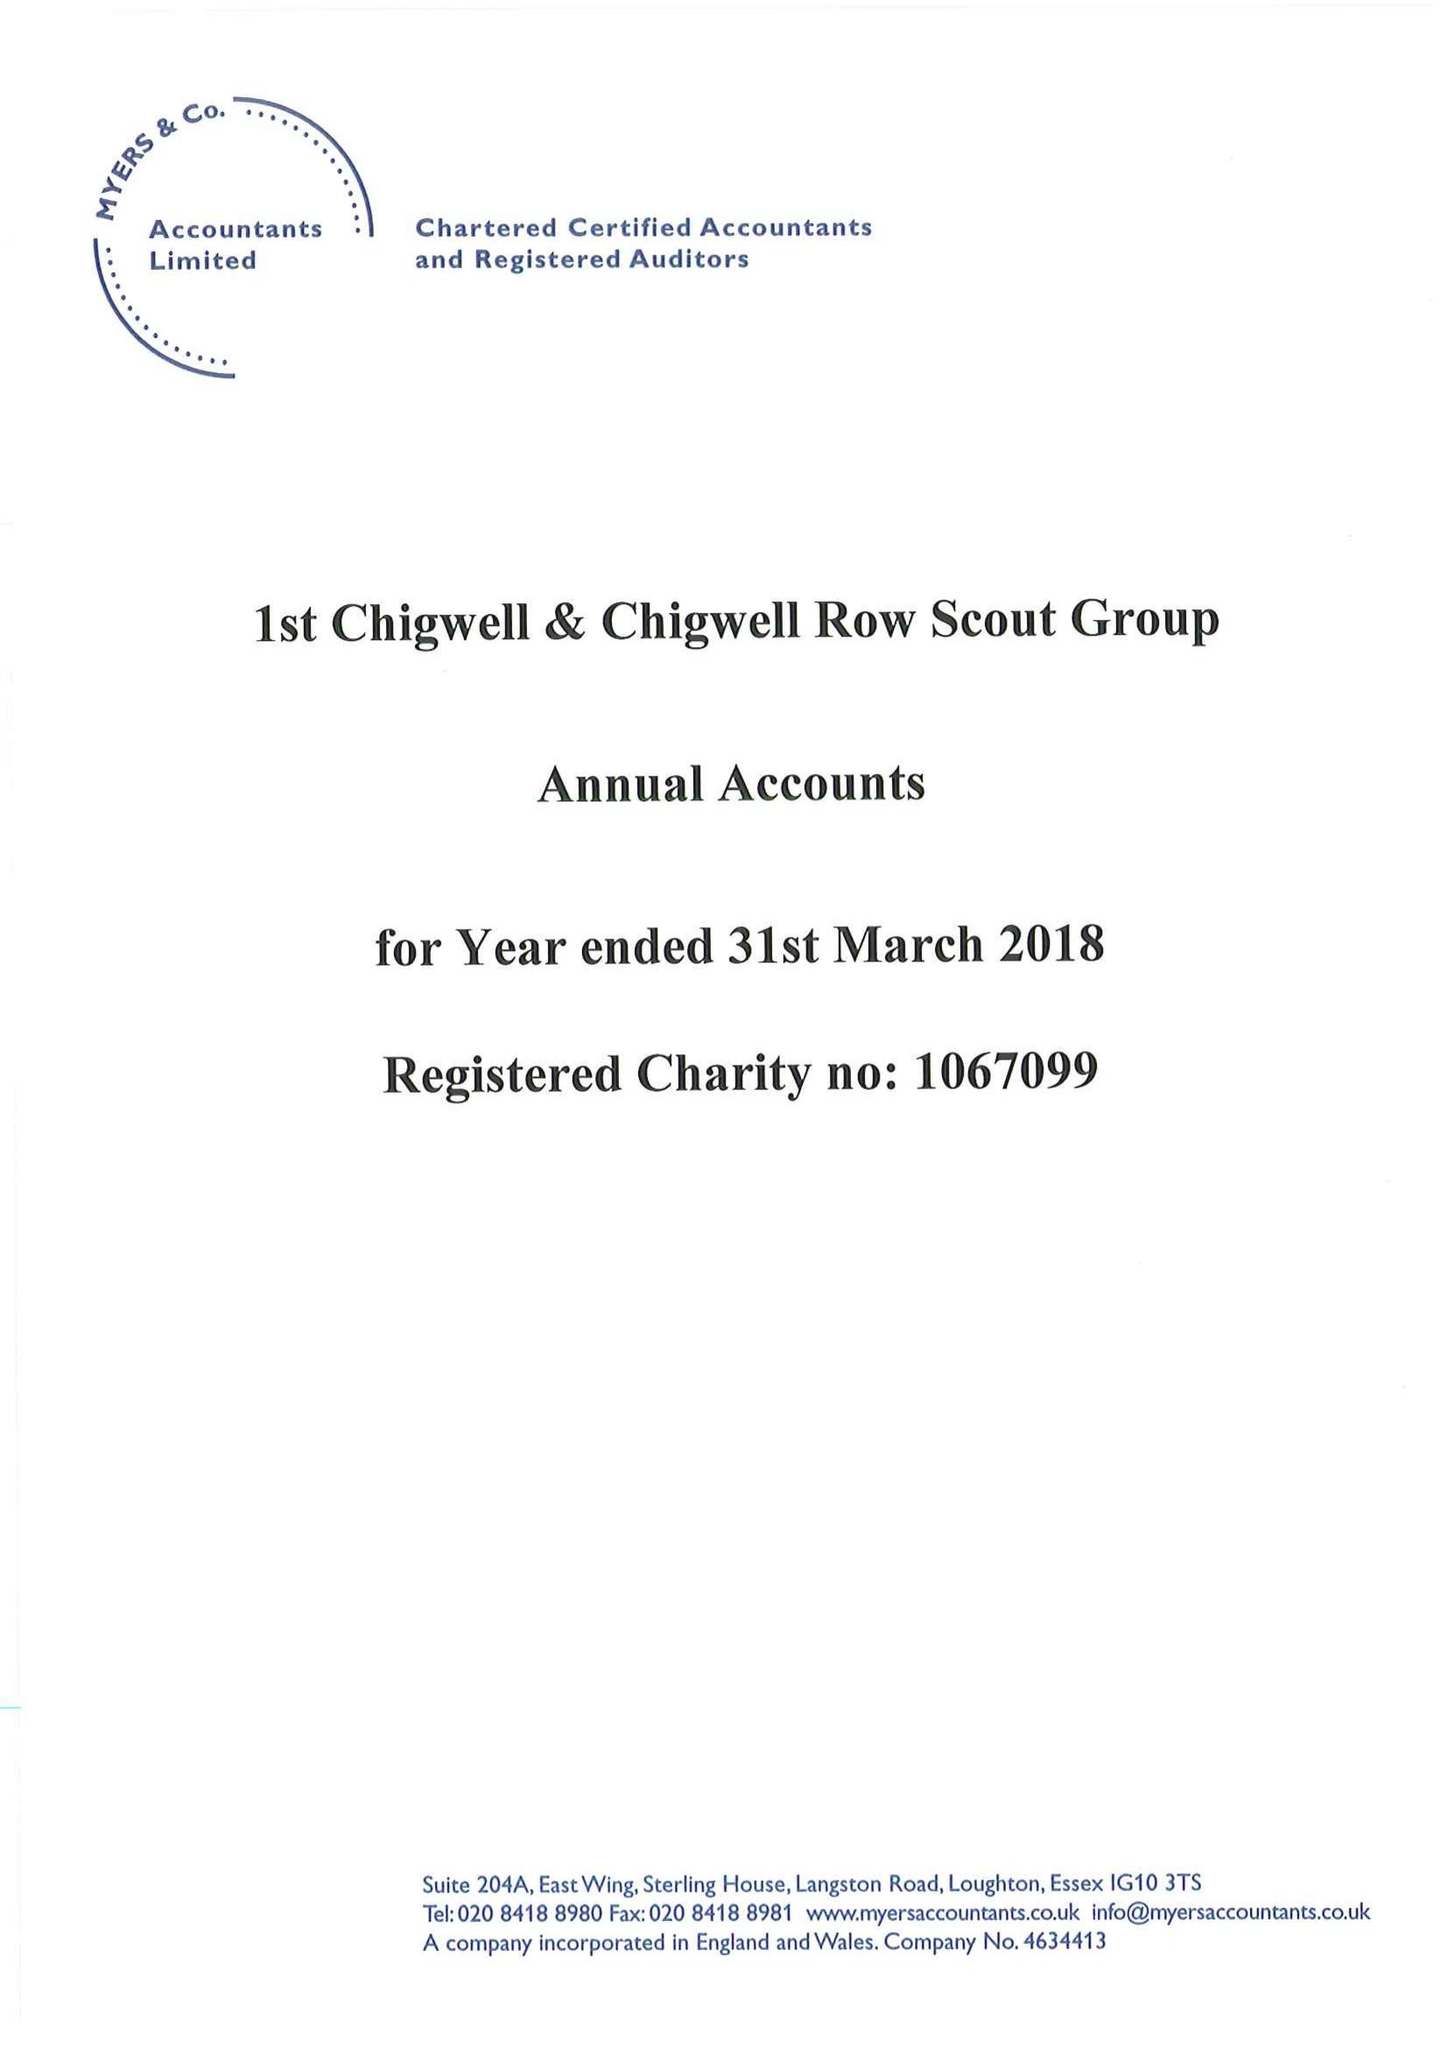What is the value for the charity_number?
Answer the question using a single word or phrase. 1067099 